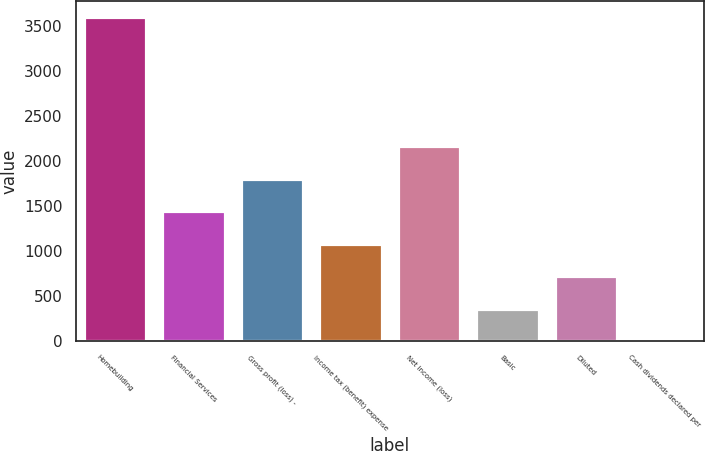Convert chart to OTSL. <chart><loc_0><loc_0><loc_500><loc_500><bar_chart><fcel>Homebuilding<fcel>Financial Services<fcel>Gross profit (loss) -<fcel>Income tax (benefit) expense<fcel>Net income (loss)<fcel>Basic<fcel>Diluted<fcel>Cash dividends declared per<nl><fcel>3603.9<fcel>1441.63<fcel>1802.01<fcel>1081.26<fcel>2162.39<fcel>360.52<fcel>720.89<fcel>0.15<nl></chart> 